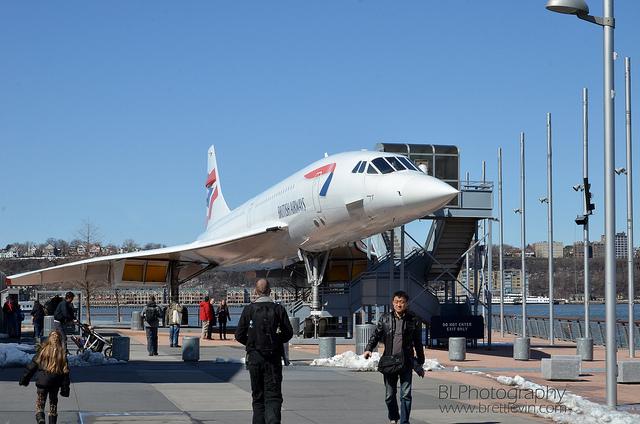Is this a passenger plane?
Short answer required. Yes. Is there a watermark on the picture?
Concise answer only. Yes. Are the two men on the right facing the camera?
Keep it brief. No. Is the airplane flying?
Quick response, please. No. Is the sky clear?
Be succinct. Yes. 